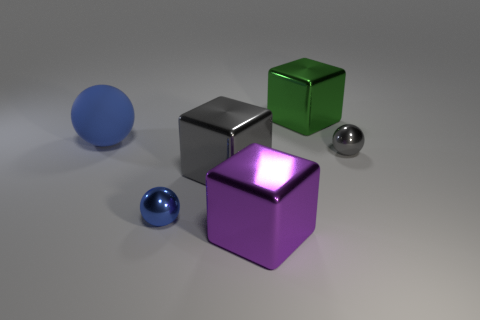Are there any other things that have the same material as the big ball?
Offer a terse response. No. What is the shape of the blue object that is on the right side of the large blue ball?
Ensure brevity in your answer.  Sphere. There is a gray ball that is the same material as the big green thing; what is its size?
Keep it short and to the point. Small. What shape is the object that is both behind the gray metallic sphere and right of the blue shiny object?
Ensure brevity in your answer.  Cube. There is a small metallic object that is in front of the big gray object; is its color the same as the large matte thing?
Make the answer very short. Yes. There is a small object on the right side of the gray block; does it have the same shape as the big thing that is left of the small blue ball?
Offer a terse response. Yes. There is a metal cube that is behind the big blue rubber ball; what is its size?
Offer a very short reply. Large. There is a metal block behind the blue ball left of the tiny blue ball; how big is it?
Offer a very short reply. Large. Are there more tiny purple metal blocks than blue shiny balls?
Offer a very short reply. No. Are there more blue things to the right of the matte object than tiny blue balls in front of the purple object?
Provide a succinct answer. Yes. 